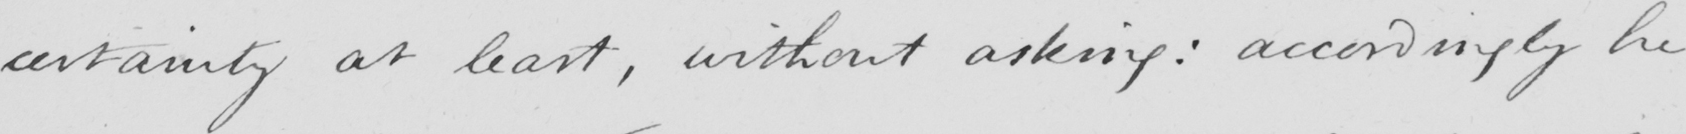Please transcribe the handwritten text in this image. certainty at least , without asking :  accordingly he 